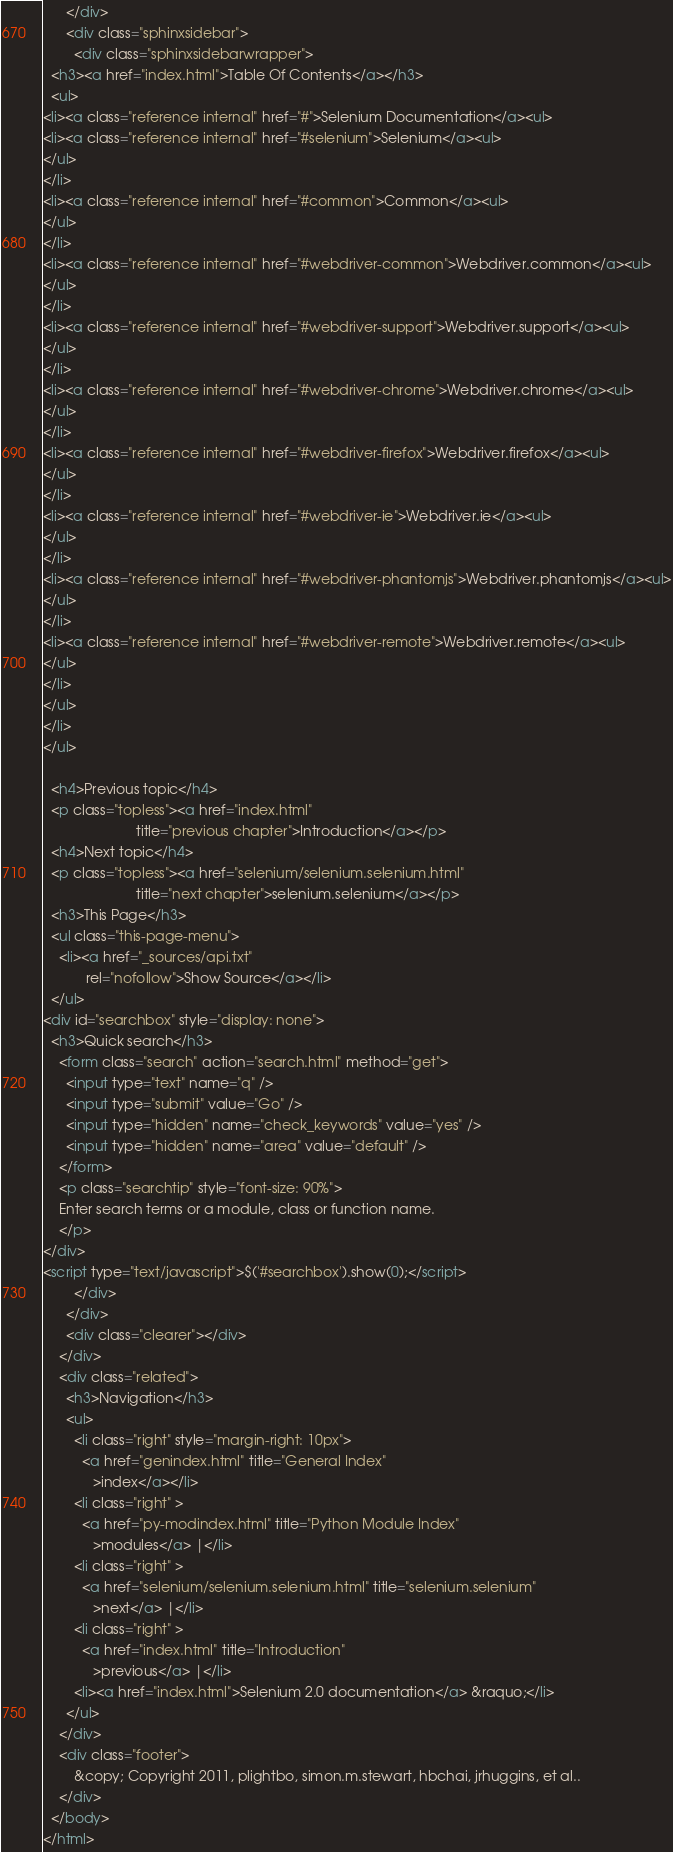Convert code to text. <code><loc_0><loc_0><loc_500><loc_500><_HTML_>      </div>
      <div class="sphinxsidebar">
        <div class="sphinxsidebarwrapper">
  <h3><a href="index.html">Table Of Contents</a></h3>
  <ul>
<li><a class="reference internal" href="#">Selenium Documentation</a><ul>
<li><a class="reference internal" href="#selenium">Selenium</a><ul>
</ul>
</li>
<li><a class="reference internal" href="#common">Common</a><ul>
</ul>
</li>
<li><a class="reference internal" href="#webdriver-common">Webdriver.common</a><ul>
</ul>
</li>
<li><a class="reference internal" href="#webdriver-support">Webdriver.support</a><ul>
</ul>
</li>
<li><a class="reference internal" href="#webdriver-chrome">Webdriver.chrome</a><ul>
</ul>
</li>
<li><a class="reference internal" href="#webdriver-firefox">Webdriver.firefox</a><ul>
</ul>
</li>
<li><a class="reference internal" href="#webdriver-ie">Webdriver.ie</a><ul>
</ul>
</li>
<li><a class="reference internal" href="#webdriver-phantomjs">Webdriver.phantomjs</a><ul>
</ul>
</li>
<li><a class="reference internal" href="#webdriver-remote">Webdriver.remote</a><ul>
</ul>
</li>
</ul>
</li>
</ul>

  <h4>Previous topic</h4>
  <p class="topless"><a href="index.html"
                        title="previous chapter">Introduction</a></p>
  <h4>Next topic</h4>
  <p class="topless"><a href="selenium/selenium.selenium.html"
                        title="next chapter">selenium.selenium</a></p>
  <h3>This Page</h3>
  <ul class="this-page-menu">
    <li><a href="_sources/api.txt"
           rel="nofollow">Show Source</a></li>
  </ul>
<div id="searchbox" style="display: none">
  <h3>Quick search</h3>
    <form class="search" action="search.html" method="get">
      <input type="text" name="q" />
      <input type="submit" value="Go" />
      <input type="hidden" name="check_keywords" value="yes" />
      <input type="hidden" name="area" value="default" />
    </form>
    <p class="searchtip" style="font-size: 90%">
    Enter search terms or a module, class or function name.
    </p>
</div>
<script type="text/javascript">$('#searchbox').show(0);</script>
        </div>
      </div>
      <div class="clearer"></div>
    </div>
    <div class="related">
      <h3>Navigation</h3>
      <ul>
        <li class="right" style="margin-right: 10px">
          <a href="genindex.html" title="General Index"
             >index</a></li>
        <li class="right" >
          <a href="py-modindex.html" title="Python Module Index"
             >modules</a> |</li>
        <li class="right" >
          <a href="selenium/selenium.selenium.html" title="selenium.selenium"
             >next</a> |</li>
        <li class="right" >
          <a href="index.html" title="Introduction"
             >previous</a> |</li>
        <li><a href="index.html">Selenium 2.0 documentation</a> &raquo;</li> 
      </ul>
    </div>
    <div class="footer">
        &copy; Copyright 2011, plightbo, simon.m.stewart, hbchai, jrhuggins, et al..
    </div>
  </body>
</html></code> 